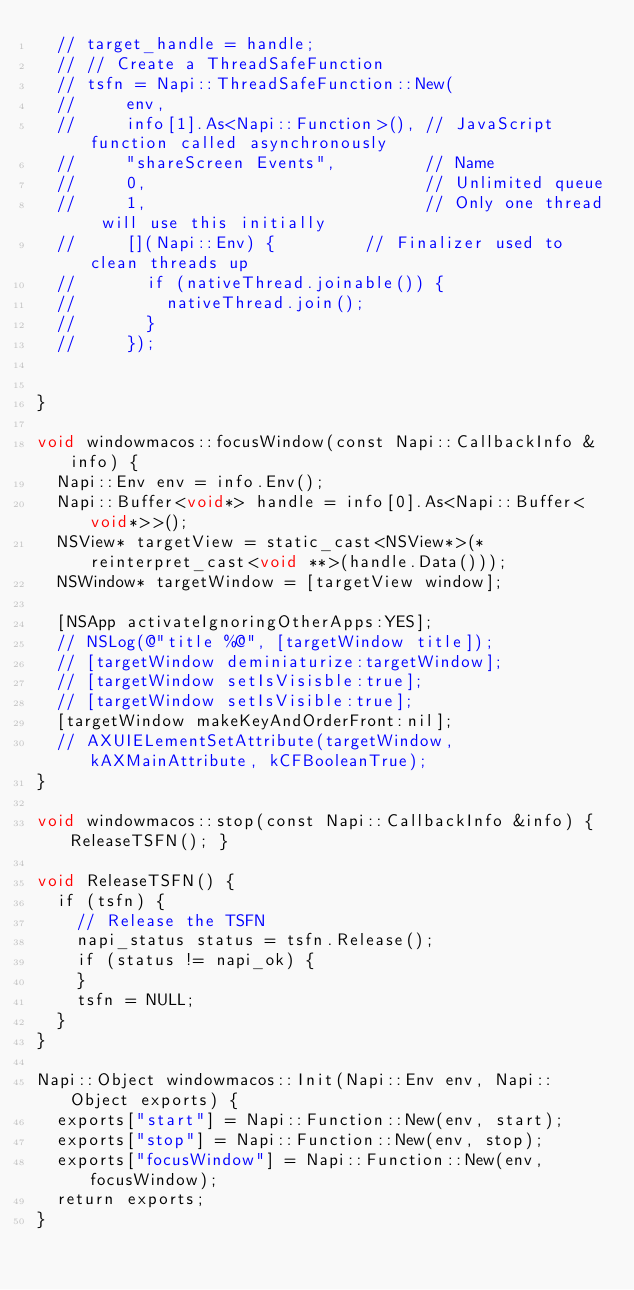Convert code to text. <code><loc_0><loc_0><loc_500><loc_500><_ObjectiveC_>  // target_handle = handle;
  // // Create a ThreadSafeFunction
  // tsfn = Napi::ThreadSafeFunction::New(
  //     env,
  //     info[1].As<Napi::Function>(), // JavaScript function called asynchronously
  //     "shareScreen Events",         // Name
  //     0,                            // Unlimited queue
  //     1,                            // Only one thread will use this initially
  //     [](Napi::Env) {         // Finalizer used to clean threads up
  //       if (nativeThread.joinable()) {
  //         nativeThread.join();
  //       }
  //     });


}

void windowmacos::focusWindow(const Napi::CallbackInfo &info) {
  Napi::Env env = info.Env();
  Napi::Buffer<void*> handle = info[0].As<Napi::Buffer<void*>>();
  NSView* targetView = static_cast<NSView*>(*reinterpret_cast<void **>(handle.Data()));
  NSWindow* targetWindow = [targetView window];
  
  [NSApp activateIgnoringOtherApps:YES];
  // NSLog(@"title %@", [targetWindow title]);
  // [targetWindow deminiaturize:targetWindow];
  // [targetWindow setIsVisisble:true];
  // [targetWindow setIsVisible:true];
  [targetWindow makeKeyAndOrderFront:nil];
  // AXUIELementSetAttribute(targetWindow, kAXMainAttribute, kCFBooleanTrue);
}

void windowmacos::stop(const Napi::CallbackInfo &info) { ReleaseTSFN(); }

void ReleaseTSFN() {
  if (tsfn) {
    // Release the TSFN
    napi_status status = tsfn.Release();
    if (status != napi_ok) {
    }
    tsfn = NULL;
  }
}

Napi::Object windowmacos::Init(Napi::Env env, Napi::Object exports) {
  exports["start"] = Napi::Function::New(env, start);
  exports["stop"] = Napi::Function::New(env, stop);
  exports["focusWindow"] = Napi::Function::New(env, focusWindow);
  return exports;
}</code> 